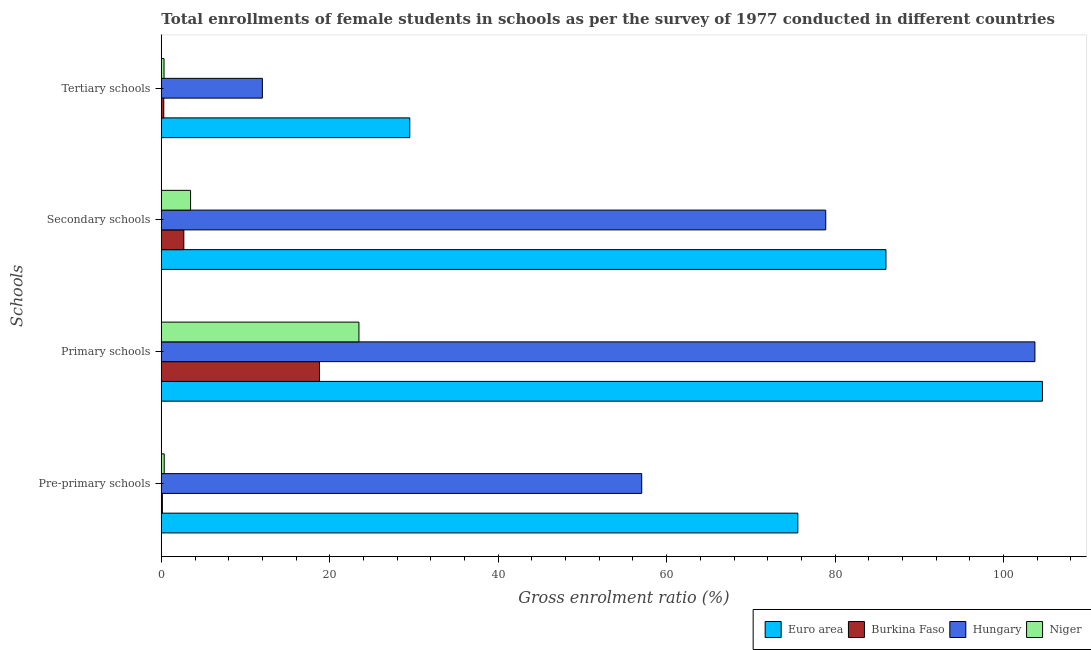How many different coloured bars are there?
Your response must be concise. 4. How many groups of bars are there?
Your answer should be compact. 4. Are the number of bars per tick equal to the number of legend labels?
Make the answer very short. Yes. Are the number of bars on each tick of the Y-axis equal?
Ensure brevity in your answer.  Yes. How many bars are there on the 1st tick from the top?
Offer a terse response. 4. How many bars are there on the 2nd tick from the bottom?
Offer a terse response. 4. What is the label of the 2nd group of bars from the top?
Provide a succinct answer. Secondary schools. What is the gross enrolment ratio(female) in pre-primary schools in Hungary?
Give a very brief answer. 57.04. Across all countries, what is the maximum gross enrolment ratio(female) in pre-primary schools?
Provide a succinct answer. 75.58. Across all countries, what is the minimum gross enrolment ratio(female) in primary schools?
Ensure brevity in your answer.  18.78. In which country was the gross enrolment ratio(female) in primary schools minimum?
Ensure brevity in your answer.  Burkina Faso. What is the total gross enrolment ratio(female) in pre-primary schools in the graph?
Offer a terse response. 133.09. What is the difference between the gross enrolment ratio(female) in primary schools in Euro area and that in Hungary?
Offer a terse response. 0.89. What is the difference between the gross enrolment ratio(female) in tertiary schools in Burkina Faso and the gross enrolment ratio(female) in pre-primary schools in Niger?
Provide a succinct answer. -0.05. What is the average gross enrolment ratio(female) in primary schools per country?
Ensure brevity in your answer.  62.65. What is the difference between the gross enrolment ratio(female) in pre-primary schools and gross enrolment ratio(female) in tertiary schools in Burkina Faso?
Make the answer very short. -0.16. What is the ratio of the gross enrolment ratio(female) in primary schools in Euro area to that in Burkina Faso?
Make the answer very short. 5.57. Is the gross enrolment ratio(female) in secondary schools in Hungary less than that in Euro area?
Offer a very short reply. Yes. Is the difference between the gross enrolment ratio(female) in pre-primary schools in Euro area and Hungary greater than the difference between the gross enrolment ratio(female) in tertiary schools in Euro area and Hungary?
Provide a short and direct response. Yes. What is the difference between the highest and the second highest gross enrolment ratio(female) in secondary schools?
Your answer should be very brief. 7.15. What is the difference between the highest and the lowest gross enrolment ratio(female) in primary schools?
Your answer should be compact. 85.84. In how many countries, is the gross enrolment ratio(female) in tertiary schools greater than the average gross enrolment ratio(female) in tertiary schools taken over all countries?
Your answer should be very brief. 2. Is the sum of the gross enrolment ratio(female) in primary schools in Euro area and Niger greater than the maximum gross enrolment ratio(female) in tertiary schools across all countries?
Offer a very short reply. Yes. What does the 4th bar from the top in Primary schools represents?
Ensure brevity in your answer.  Euro area. Is it the case that in every country, the sum of the gross enrolment ratio(female) in pre-primary schools and gross enrolment ratio(female) in primary schools is greater than the gross enrolment ratio(female) in secondary schools?
Offer a terse response. Yes. How many bars are there?
Make the answer very short. 16. How many countries are there in the graph?
Provide a succinct answer. 4. Where does the legend appear in the graph?
Ensure brevity in your answer.  Bottom right. How many legend labels are there?
Your answer should be compact. 4. How are the legend labels stacked?
Ensure brevity in your answer.  Horizontal. What is the title of the graph?
Your response must be concise. Total enrollments of female students in schools as per the survey of 1977 conducted in different countries. Does "Latvia" appear as one of the legend labels in the graph?
Offer a very short reply. No. What is the label or title of the Y-axis?
Your response must be concise. Schools. What is the Gross enrolment ratio (%) in Euro area in Pre-primary schools?
Your response must be concise. 75.58. What is the Gross enrolment ratio (%) of Burkina Faso in Pre-primary schools?
Ensure brevity in your answer.  0.13. What is the Gross enrolment ratio (%) of Hungary in Pre-primary schools?
Provide a short and direct response. 57.04. What is the Gross enrolment ratio (%) of Niger in Pre-primary schools?
Ensure brevity in your answer.  0.34. What is the Gross enrolment ratio (%) of Euro area in Primary schools?
Make the answer very short. 104.62. What is the Gross enrolment ratio (%) in Burkina Faso in Primary schools?
Your response must be concise. 18.78. What is the Gross enrolment ratio (%) in Hungary in Primary schools?
Your answer should be very brief. 103.73. What is the Gross enrolment ratio (%) of Niger in Primary schools?
Provide a short and direct response. 23.46. What is the Gross enrolment ratio (%) of Euro area in Secondary schools?
Your response must be concise. 86.04. What is the Gross enrolment ratio (%) in Burkina Faso in Secondary schools?
Ensure brevity in your answer.  2.67. What is the Gross enrolment ratio (%) of Hungary in Secondary schools?
Offer a very short reply. 78.89. What is the Gross enrolment ratio (%) of Niger in Secondary schools?
Your answer should be very brief. 3.48. What is the Gross enrolment ratio (%) of Euro area in Tertiary schools?
Offer a terse response. 29.5. What is the Gross enrolment ratio (%) in Burkina Faso in Tertiary schools?
Your answer should be very brief. 0.29. What is the Gross enrolment ratio (%) in Hungary in Tertiary schools?
Provide a short and direct response. 12. What is the Gross enrolment ratio (%) of Niger in Tertiary schools?
Your answer should be very brief. 0.32. Across all Schools, what is the maximum Gross enrolment ratio (%) in Euro area?
Ensure brevity in your answer.  104.62. Across all Schools, what is the maximum Gross enrolment ratio (%) in Burkina Faso?
Provide a short and direct response. 18.78. Across all Schools, what is the maximum Gross enrolment ratio (%) of Hungary?
Provide a short and direct response. 103.73. Across all Schools, what is the maximum Gross enrolment ratio (%) of Niger?
Your response must be concise. 23.46. Across all Schools, what is the minimum Gross enrolment ratio (%) of Euro area?
Make the answer very short. 29.5. Across all Schools, what is the minimum Gross enrolment ratio (%) of Burkina Faso?
Offer a very short reply. 0.13. Across all Schools, what is the minimum Gross enrolment ratio (%) of Hungary?
Provide a short and direct response. 12. Across all Schools, what is the minimum Gross enrolment ratio (%) of Niger?
Keep it short and to the point. 0.32. What is the total Gross enrolment ratio (%) of Euro area in the graph?
Your answer should be compact. 295.74. What is the total Gross enrolment ratio (%) of Burkina Faso in the graph?
Ensure brevity in your answer.  21.87. What is the total Gross enrolment ratio (%) of Hungary in the graph?
Offer a very short reply. 251.66. What is the total Gross enrolment ratio (%) in Niger in the graph?
Make the answer very short. 27.61. What is the difference between the Gross enrolment ratio (%) of Euro area in Pre-primary schools and that in Primary schools?
Your answer should be compact. -29.04. What is the difference between the Gross enrolment ratio (%) of Burkina Faso in Pre-primary schools and that in Primary schools?
Your response must be concise. -18.65. What is the difference between the Gross enrolment ratio (%) of Hungary in Pre-primary schools and that in Primary schools?
Keep it short and to the point. -46.69. What is the difference between the Gross enrolment ratio (%) of Niger in Pre-primary schools and that in Primary schools?
Provide a short and direct response. -23.12. What is the difference between the Gross enrolment ratio (%) in Euro area in Pre-primary schools and that in Secondary schools?
Make the answer very short. -10.46. What is the difference between the Gross enrolment ratio (%) of Burkina Faso in Pre-primary schools and that in Secondary schools?
Offer a terse response. -2.55. What is the difference between the Gross enrolment ratio (%) in Hungary in Pre-primary schools and that in Secondary schools?
Provide a succinct answer. -21.85. What is the difference between the Gross enrolment ratio (%) in Niger in Pre-primary schools and that in Secondary schools?
Offer a very short reply. -3.13. What is the difference between the Gross enrolment ratio (%) in Euro area in Pre-primary schools and that in Tertiary schools?
Provide a succinct answer. 46.07. What is the difference between the Gross enrolment ratio (%) of Burkina Faso in Pre-primary schools and that in Tertiary schools?
Offer a very short reply. -0.16. What is the difference between the Gross enrolment ratio (%) of Hungary in Pre-primary schools and that in Tertiary schools?
Make the answer very short. 45.04. What is the difference between the Gross enrolment ratio (%) in Niger in Pre-primary schools and that in Tertiary schools?
Ensure brevity in your answer.  0.02. What is the difference between the Gross enrolment ratio (%) in Euro area in Primary schools and that in Secondary schools?
Give a very brief answer. 18.58. What is the difference between the Gross enrolment ratio (%) in Burkina Faso in Primary schools and that in Secondary schools?
Give a very brief answer. 16.1. What is the difference between the Gross enrolment ratio (%) of Hungary in Primary schools and that in Secondary schools?
Offer a terse response. 24.84. What is the difference between the Gross enrolment ratio (%) of Niger in Primary schools and that in Secondary schools?
Ensure brevity in your answer.  19.99. What is the difference between the Gross enrolment ratio (%) of Euro area in Primary schools and that in Tertiary schools?
Offer a very short reply. 75.12. What is the difference between the Gross enrolment ratio (%) of Burkina Faso in Primary schools and that in Tertiary schools?
Provide a succinct answer. 18.49. What is the difference between the Gross enrolment ratio (%) of Hungary in Primary schools and that in Tertiary schools?
Your answer should be compact. 91.73. What is the difference between the Gross enrolment ratio (%) of Niger in Primary schools and that in Tertiary schools?
Your response must be concise. 23.14. What is the difference between the Gross enrolment ratio (%) of Euro area in Secondary schools and that in Tertiary schools?
Your answer should be compact. 56.54. What is the difference between the Gross enrolment ratio (%) of Burkina Faso in Secondary schools and that in Tertiary schools?
Offer a terse response. 2.38. What is the difference between the Gross enrolment ratio (%) of Hungary in Secondary schools and that in Tertiary schools?
Give a very brief answer. 66.89. What is the difference between the Gross enrolment ratio (%) in Niger in Secondary schools and that in Tertiary schools?
Ensure brevity in your answer.  3.15. What is the difference between the Gross enrolment ratio (%) in Euro area in Pre-primary schools and the Gross enrolment ratio (%) in Burkina Faso in Primary schools?
Provide a short and direct response. 56.8. What is the difference between the Gross enrolment ratio (%) in Euro area in Pre-primary schools and the Gross enrolment ratio (%) in Hungary in Primary schools?
Provide a succinct answer. -28.15. What is the difference between the Gross enrolment ratio (%) of Euro area in Pre-primary schools and the Gross enrolment ratio (%) of Niger in Primary schools?
Give a very brief answer. 52.11. What is the difference between the Gross enrolment ratio (%) in Burkina Faso in Pre-primary schools and the Gross enrolment ratio (%) in Hungary in Primary schools?
Ensure brevity in your answer.  -103.6. What is the difference between the Gross enrolment ratio (%) of Burkina Faso in Pre-primary schools and the Gross enrolment ratio (%) of Niger in Primary schools?
Give a very brief answer. -23.34. What is the difference between the Gross enrolment ratio (%) in Hungary in Pre-primary schools and the Gross enrolment ratio (%) in Niger in Primary schools?
Your response must be concise. 33.58. What is the difference between the Gross enrolment ratio (%) of Euro area in Pre-primary schools and the Gross enrolment ratio (%) of Burkina Faso in Secondary schools?
Your answer should be compact. 72.9. What is the difference between the Gross enrolment ratio (%) of Euro area in Pre-primary schools and the Gross enrolment ratio (%) of Hungary in Secondary schools?
Your answer should be very brief. -3.31. What is the difference between the Gross enrolment ratio (%) of Euro area in Pre-primary schools and the Gross enrolment ratio (%) of Niger in Secondary schools?
Offer a terse response. 72.1. What is the difference between the Gross enrolment ratio (%) of Burkina Faso in Pre-primary schools and the Gross enrolment ratio (%) of Hungary in Secondary schools?
Keep it short and to the point. -78.77. What is the difference between the Gross enrolment ratio (%) of Burkina Faso in Pre-primary schools and the Gross enrolment ratio (%) of Niger in Secondary schools?
Your answer should be very brief. -3.35. What is the difference between the Gross enrolment ratio (%) in Hungary in Pre-primary schools and the Gross enrolment ratio (%) in Niger in Secondary schools?
Give a very brief answer. 53.56. What is the difference between the Gross enrolment ratio (%) of Euro area in Pre-primary schools and the Gross enrolment ratio (%) of Burkina Faso in Tertiary schools?
Your answer should be compact. 75.29. What is the difference between the Gross enrolment ratio (%) of Euro area in Pre-primary schools and the Gross enrolment ratio (%) of Hungary in Tertiary schools?
Your response must be concise. 63.57. What is the difference between the Gross enrolment ratio (%) in Euro area in Pre-primary schools and the Gross enrolment ratio (%) in Niger in Tertiary schools?
Offer a very short reply. 75.25. What is the difference between the Gross enrolment ratio (%) of Burkina Faso in Pre-primary schools and the Gross enrolment ratio (%) of Hungary in Tertiary schools?
Give a very brief answer. -11.88. What is the difference between the Gross enrolment ratio (%) of Burkina Faso in Pre-primary schools and the Gross enrolment ratio (%) of Niger in Tertiary schools?
Provide a short and direct response. -0.2. What is the difference between the Gross enrolment ratio (%) of Hungary in Pre-primary schools and the Gross enrolment ratio (%) of Niger in Tertiary schools?
Offer a very short reply. 56.72. What is the difference between the Gross enrolment ratio (%) of Euro area in Primary schools and the Gross enrolment ratio (%) of Burkina Faso in Secondary schools?
Give a very brief answer. 101.95. What is the difference between the Gross enrolment ratio (%) in Euro area in Primary schools and the Gross enrolment ratio (%) in Hungary in Secondary schools?
Offer a terse response. 25.73. What is the difference between the Gross enrolment ratio (%) in Euro area in Primary schools and the Gross enrolment ratio (%) in Niger in Secondary schools?
Your answer should be very brief. 101.14. What is the difference between the Gross enrolment ratio (%) in Burkina Faso in Primary schools and the Gross enrolment ratio (%) in Hungary in Secondary schools?
Ensure brevity in your answer.  -60.11. What is the difference between the Gross enrolment ratio (%) in Burkina Faso in Primary schools and the Gross enrolment ratio (%) in Niger in Secondary schools?
Your answer should be very brief. 15.3. What is the difference between the Gross enrolment ratio (%) in Hungary in Primary schools and the Gross enrolment ratio (%) in Niger in Secondary schools?
Offer a terse response. 100.25. What is the difference between the Gross enrolment ratio (%) in Euro area in Primary schools and the Gross enrolment ratio (%) in Burkina Faso in Tertiary schools?
Give a very brief answer. 104.33. What is the difference between the Gross enrolment ratio (%) of Euro area in Primary schools and the Gross enrolment ratio (%) of Hungary in Tertiary schools?
Keep it short and to the point. 92.62. What is the difference between the Gross enrolment ratio (%) of Euro area in Primary schools and the Gross enrolment ratio (%) of Niger in Tertiary schools?
Ensure brevity in your answer.  104.3. What is the difference between the Gross enrolment ratio (%) of Burkina Faso in Primary schools and the Gross enrolment ratio (%) of Hungary in Tertiary schools?
Make the answer very short. 6.78. What is the difference between the Gross enrolment ratio (%) in Burkina Faso in Primary schools and the Gross enrolment ratio (%) in Niger in Tertiary schools?
Provide a succinct answer. 18.45. What is the difference between the Gross enrolment ratio (%) of Hungary in Primary schools and the Gross enrolment ratio (%) of Niger in Tertiary schools?
Your answer should be very brief. 103.4. What is the difference between the Gross enrolment ratio (%) of Euro area in Secondary schools and the Gross enrolment ratio (%) of Burkina Faso in Tertiary schools?
Provide a succinct answer. 85.75. What is the difference between the Gross enrolment ratio (%) of Euro area in Secondary schools and the Gross enrolment ratio (%) of Hungary in Tertiary schools?
Offer a very short reply. 74.04. What is the difference between the Gross enrolment ratio (%) of Euro area in Secondary schools and the Gross enrolment ratio (%) of Niger in Tertiary schools?
Your response must be concise. 85.72. What is the difference between the Gross enrolment ratio (%) of Burkina Faso in Secondary schools and the Gross enrolment ratio (%) of Hungary in Tertiary schools?
Give a very brief answer. -9.33. What is the difference between the Gross enrolment ratio (%) in Burkina Faso in Secondary schools and the Gross enrolment ratio (%) in Niger in Tertiary schools?
Your answer should be compact. 2.35. What is the difference between the Gross enrolment ratio (%) of Hungary in Secondary schools and the Gross enrolment ratio (%) of Niger in Tertiary schools?
Make the answer very short. 78.57. What is the average Gross enrolment ratio (%) in Euro area per Schools?
Your answer should be very brief. 73.93. What is the average Gross enrolment ratio (%) in Burkina Faso per Schools?
Keep it short and to the point. 5.47. What is the average Gross enrolment ratio (%) of Hungary per Schools?
Offer a terse response. 62.91. What is the average Gross enrolment ratio (%) in Niger per Schools?
Offer a terse response. 6.9. What is the difference between the Gross enrolment ratio (%) of Euro area and Gross enrolment ratio (%) of Burkina Faso in Pre-primary schools?
Offer a terse response. 75.45. What is the difference between the Gross enrolment ratio (%) in Euro area and Gross enrolment ratio (%) in Hungary in Pre-primary schools?
Your answer should be compact. 18.54. What is the difference between the Gross enrolment ratio (%) of Euro area and Gross enrolment ratio (%) of Niger in Pre-primary schools?
Your response must be concise. 75.23. What is the difference between the Gross enrolment ratio (%) in Burkina Faso and Gross enrolment ratio (%) in Hungary in Pre-primary schools?
Ensure brevity in your answer.  -56.91. What is the difference between the Gross enrolment ratio (%) in Burkina Faso and Gross enrolment ratio (%) in Niger in Pre-primary schools?
Your answer should be compact. -0.22. What is the difference between the Gross enrolment ratio (%) in Hungary and Gross enrolment ratio (%) in Niger in Pre-primary schools?
Your response must be concise. 56.7. What is the difference between the Gross enrolment ratio (%) of Euro area and Gross enrolment ratio (%) of Burkina Faso in Primary schools?
Provide a short and direct response. 85.84. What is the difference between the Gross enrolment ratio (%) of Euro area and Gross enrolment ratio (%) of Hungary in Primary schools?
Provide a succinct answer. 0.89. What is the difference between the Gross enrolment ratio (%) of Euro area and Gross enrolment ratio (%) of Niger in Primary schools?
Ensure brevity in your answer.  81.15. What is the difference between the Gross enrolment ratio (%) of Burkina Faso and Gross enrolment ratio (%) of Hungary in Primary schools?
Provide a short and direct response. -84.95. What is the difference between the Gross enrolment ratio (%) in Burkina Faso and Gross enrolment ratio (%) in Niger in Primary schools?
Provide a short and direct response. -4.69. What is the difference between the Gross enrolment ratio (%) of Hungary and Gross enrolment ratio (%) of Niger in Primary schools?
Give a very brief answer. 80.26. What is the difference between the Gross enrolment ratio (%) of Euro area and Gross enrolment ratio (%) of Burkina Faso in Secondary schools?
Make the answer very short. 83.37. What is the difference between the Gross enrolment ratio (%) in Euro area and Gross enrolment ratio (%) in Hungary in Secondary schools?
Your response must be concise. 7.15. What is the difference between the Gross enrolment ratio (%) of Euro area and Gross enrolment ratio (%) of Niger in Secondary schools?
Your answer should be compact. 82.56. What is the difference between the Gross enrolment ratio (%) of Burkina Faso and Gross enrolment ratio (%) of Hungary in Secondary schools?
Your answer should be very brief. -76.22. What is the difference between the Gross enrolment ratio (%) in Burkina Faso and Gross enrolment ratio (%) in Niger in Secondary schools?
Ensure brevity in your answer.  -0.8. What is the difference between the Gross enrolment ratio (%) of Hungary and Gross enrolment ratio (%) of Niger in Secondary schools?
Make the answer very short. 75.42. What is the difference between the Gross enrolment ratio (%) of Euro area and Gross enrolment ratio (%) of Burkina Faso in Tertiary schools?
Your answer should be compact. 29.21. What is the difference between the Gross enrolment ratio (%) in Euro area and Gross enrolment ratio (%) in Hungary in Tertiary schools?
Give a very brief answer. 17.5. What is the difference between the Gross enrolment ratio (%) in Euro area and Gross enrolment ratio (%) in Niger in Tertiary schools?
Offer a very short reply. 29.18. What is the difference between the Gross enrolment ratio (%) of Burkina Faso and Gross enrolment ratio (%) of Hungary in Tertiary schools?
Provide a succinct answer. -11.71. What is the difference between the Gross enrolment ratio (%) in Burkina Faso and Gross enrolment ratio (%) in Niger in Tertiary schools?
Offer a terse response. -0.03. What is the difference between the Gross enrolment ratio (%) of Hungary and Gross enrolment ratio (%) of Niger in Tertiary schools?
Keep it short and to the point. 11.68. What is the ratio of the Gross enrolment ratio (%) in Euro area in Pre-primary schools to that in Primary schools?
Offer a very short reply. 0.72. What is the ratio of the Gross enrolment ratio (%) of Burkina Faso in Pre-primary schools to that in Primary schools?
Keep it short and to the point. 0.01. What is the ratio of the Gross enrolment ratio (%) of Hungary in Pre-primary schools to that in Primary schools?
Ensure brevity in your answer.  0.55. What is the ratio of the Gross enrolment ratio (%) of Niger in Pre-primary schools to that in Primary schools?
Your answer should be compact. 0.01. What is the ratio of the Gross enrolment ratio (%) of Euro area in Pre-primary schools to that in Secondary schools?
Your answer should be very brief. 0.88. What is the ratio of the Gross enrolment ratio (%) in Burkina Faso in Pre-primary schools to that in Secondary schools?
Provide a succinct answer. 0.05. What is the ratio of the Gross enrolment ratio (%) in Hungary in Pre-primary schools to that in Secondary schools?
Provide a short and direct response. 0.72. What is the ratio of the Gross enrolment ratio (%) of Niger in Pre-primary schools to that in Secondary schools?
Provide a short and direct response. 0.1. What is the ratio of the Gross enrolment ratio (%) in Euro area in Pre-primary schools to that in Tertiary schools?
Your answer should be compact. 2.56. What is the ratio of the Gross enrolment ratio (%) in Burkina Faso in Pre-primary schools to that in Tertiary schools?
Your answer should be compact. 0.43. What is the ratio of the Gross enrolment ratio (%) of Hungary in Pre-primary schools to that in Tertiary schools?
Make the answer very short. 4.75. What is the ratio of the Gross enrolment ratio (%) in Niger in Pre-primary schools to that in Tertiary schools?
Make the answer very short. 1.07. What is the ratio of the Gross enrolment ratio (%) in Euro area in Primary schools to that in Secondary schools?
Offer a very short reply. 1.22. What is the ratio of the Gross enrolment ratio (%) of Burkina Faso in Primary schools to that in Secondary schools?
Offer a terse response. 7.03. What is the ratio of the Gross enrolment ratio (%) in Hungary in Primary schools to that in Secondary schools?
Offer a terse response. 1.31. What is the ratio of the Gross enrolment ratio (%) in Niger in Primary schools to that in Secondary schools?
Your answer should be very brief. 6.75. What is the ratio of the Gross enrolment ratio (%) of Euro area in Primary schools to that in Tertiary schools?
Your answer should be compact. 3.55. What is the ratio of the Gross enrolment ratio (%) of Burkina Faso in Primary schools to that in Tertiary schools?
Offer a terse response. 64.55. What is the ratio of the Gross enrolment ratio (%) of Hungary in Primary schools to that in Tertiary schools?
Your answer should be very brief. 8.64. What is the ratio of the Gross enrolment ratio (%) in Niger in Primary schools to that in Tertiary schools?
Provide a short and direct response. 72.62. What is the ratio of the Gross enrolment ratio (%) in Euro area in Secondary schools to that in Tertiary schools?
Give a very brief answer. 2.92. What is the ratio of the Gross enrolment ratio (%) in Burkina Faso in Secondary schools to that in Tertiary schools?
Provide a short and direct response. 9.19. What is the ratio of the Gross enrolment ratio (%) of Hungary in Secondary schools to that in Tertiary schools?
Your answer should be compact. 6.57. What is the ratio of the Gross enrolment ratio (%) of Niger in Secondary schools to that in Tertiary schools?
Give a very brief answer. 10.76. What is the difference between the highest and the second highest Gross enrolment ratio (%) of Euro area?
Provide a succinct answer. 18.58. What is the difference between the highest and the second highest Gross enrolment ratio (%) of Burkina Faso?
Provide a short and direct response. 16.1. What is the difference between the highest and the second highest Gross enrolment ratio (%) in Hungary?
Ensure brevity in your answer.  24.84. What is the difference between the highest and the second highest Gross enrolment ratio (%) of Niger?
Make the answer very short. 19.99. What is the difference between the highest and the lowest Gross enrolment ratio (%) in Euro area?
Make the answer very short. 75.12. What is the difference between the highest and the lowest Gross enrolment ratio (%) of Burkina Faso?
Provide a succinct answer. 18.65. What is the difference between the highest and the lowest Gross enrolment ratio (%) of Hungary?
Give a very brief answer. 91.73. What is the difference between the highest and the lowest Gross enrolment ratio (%) in Niger?
Provide a short and direct response. 23.14. 